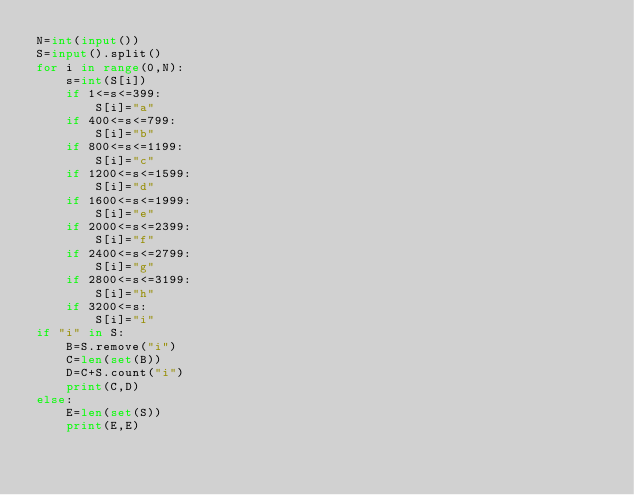<code> <loc_0><loc_0><loc_500><loc_500><_Python_>N=int(input())
S=input().split()
for i in range(0,N):
    s=int(S[i])
    if 1<=s<=399:
        S[i]="a"
    if 400<=s<=799:
        S[i]="b"
    if 800<=s<=1199:
        S[i]="c"
    if 1200<=s<=1599:
        S[i]="d"
    if 1600<=s<=1999:
        S[i]="e"
    if 2000<=s<=2399:
        S[i]="f"
    if 2400<=s<=2799:
        S[i]="g"
    if 2800<=s<=3199:
        S[i]="h"
    if 3200<=s:
        S[i]="i"
if "i" in S:
    B=S.remove("i")
    C=len(set(B)) 
    D=C+S.count("i")
    print(C,D)
else:
    E=len(set(S))
    print(E,E)</code> 